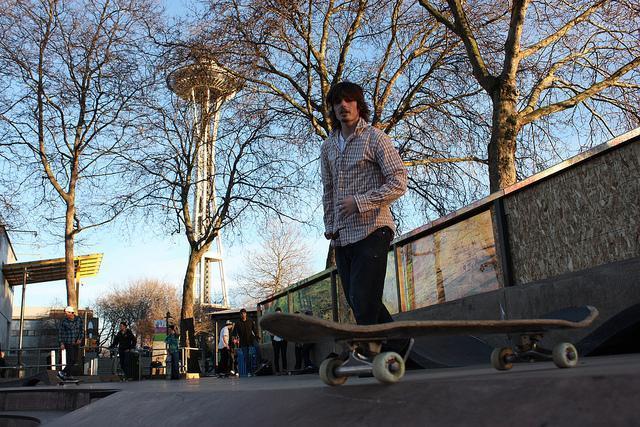How many wheels are on the skateboard?
Give a very brief answer. 4. How many cats are on the top shelf?
Give a very brief answer. 0. 